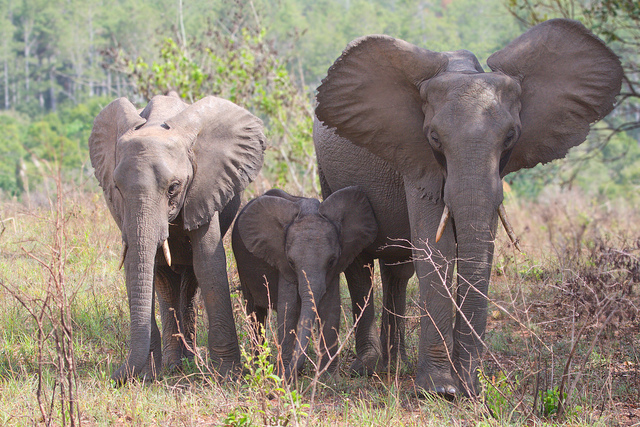What time of day does it seem to be in this photo? Based on the soft lighting and lack of harsh shadows, it appears to be either early morning or late afternoon, which are typically the cooler parts of the day when elephants are more active. 